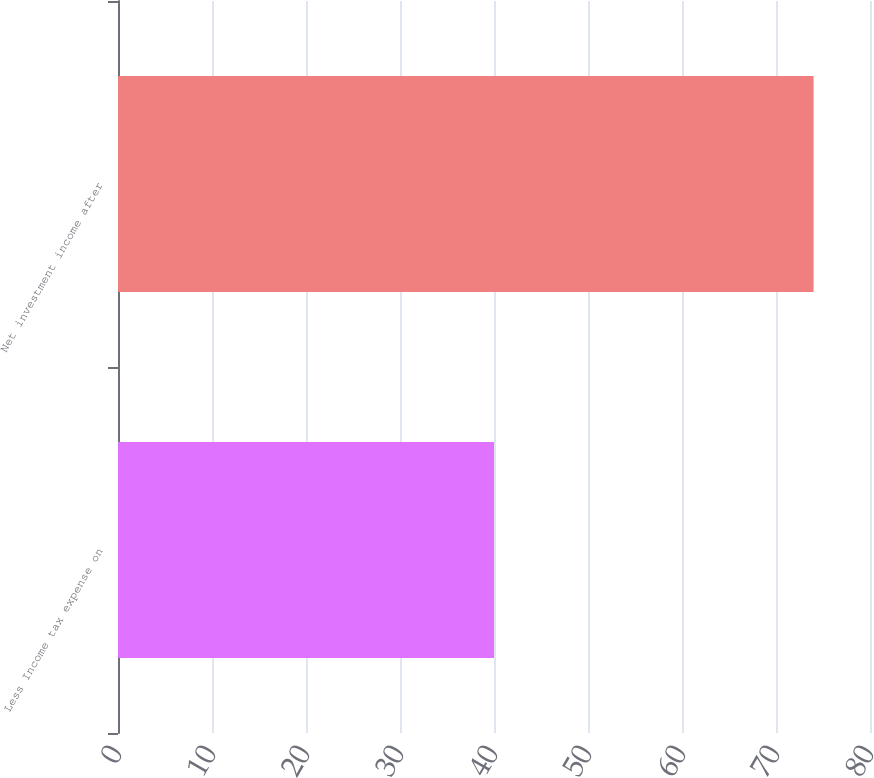Convert chart to OTSL. <chart><loc_0><loc_0><loc_500><loc_500><bar_chart><fcel>Less Income tax expense on<fcel>Net investment income after<nl><fcel>40<fcel>74<nl></chart> 